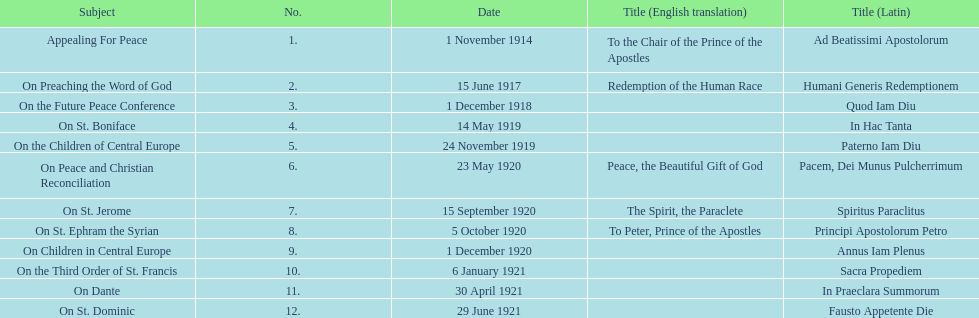What are the number of titles with a date of november? 2. 